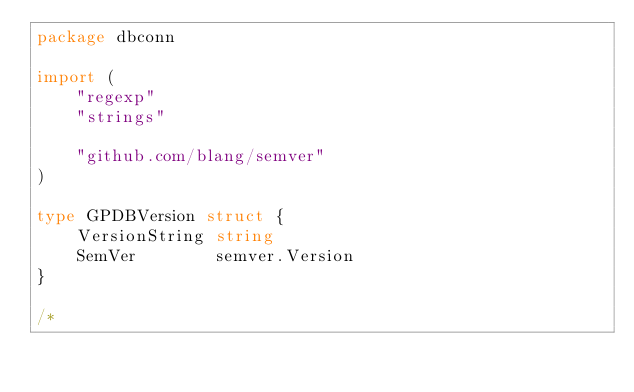<code> <loc_0><loc_0><loc_500><loc_500><_Go_>package dbconn

import (
	"regexp"
	"strings"

	"github.com/blang/semver"
)

type GPDBVersion struct {
	VersionString string
	SemVer        semver.Version
}

/*</code> 